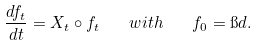<formula> <loc_0><loc_0><loc_500><loc_500>\frac { d f _ { t } } { d t } = X _ { t } \circ f _ { t } \quad w i t h \quad f _ { 0 } = \i d .</formula> 